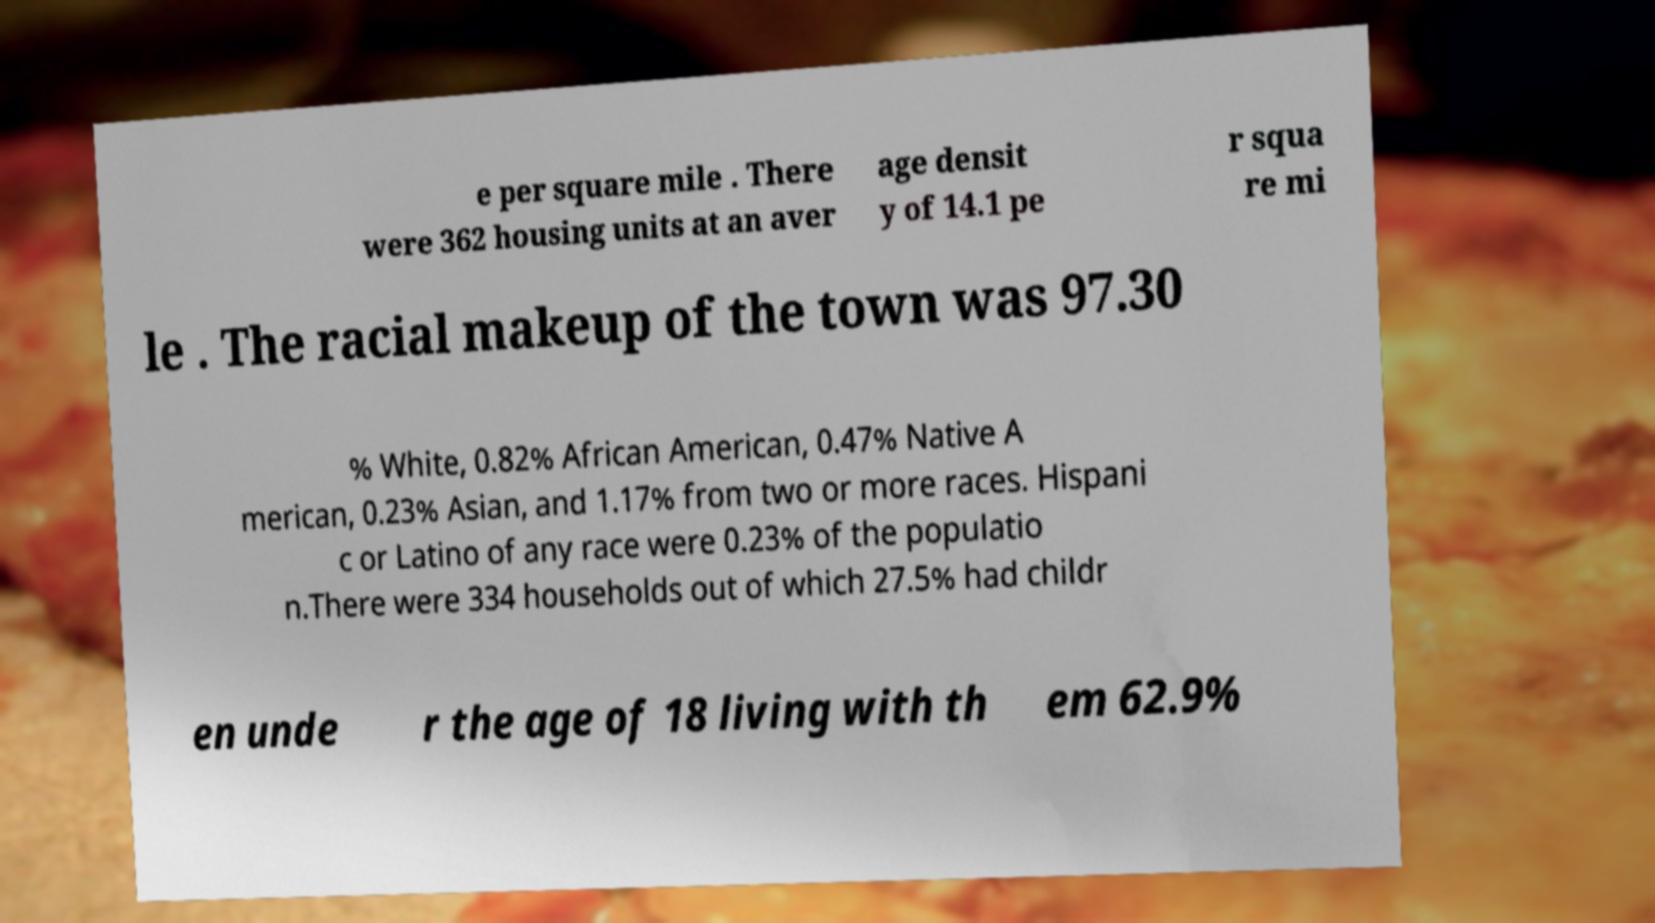Could you assist in decoding the text presented in this image and type it out clearly? e per square mile . There were 362 housing units at an aver age densit y of 14.1 pe r squa re mi le . The racial makeup of the town was 97.30 % White, 0.82% African American, 0.47% Native A merican, 0.23% Asian, and 1.17% from two or more races. Hispani c or Latino of any race were 0.23% of the populatio n.There were 334 households out of which 27.5% had childr en unde r the age of 18 living with th em 62.9% 